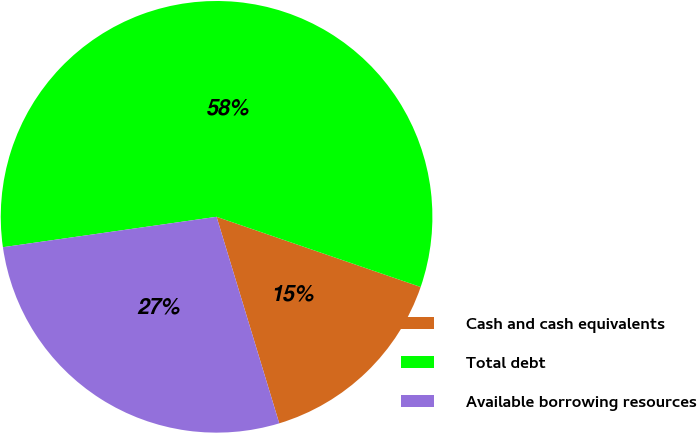Convert chart to OTSL. <chart><loc_0><loc_0><loc_500><loc_500><pie_chart><fcel>Cash and cash equivalents<fcel>Total debt<fcel>Available borrowing resources<nl><fcel>15.04%<fcel>57.52%<fcel>27.44%<nl></chart> 